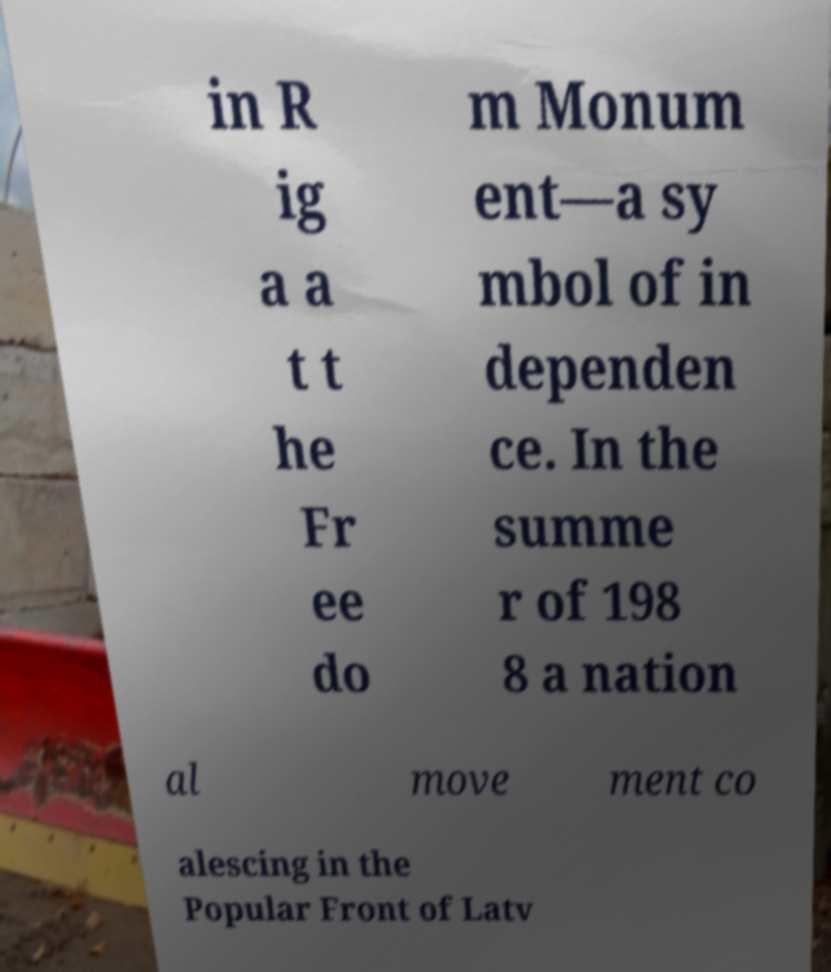Could you extract and type out the text from this image? in R ig a a t t he Fr ee do m Monum ent—a sy mbol of in dependen ce. In the summe r of 198 8 a nation al move ment co alescing in the Popular Front of Latv 